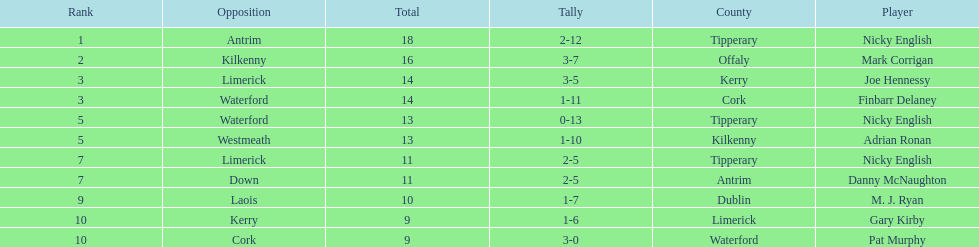What is the least total on the list? 9. 